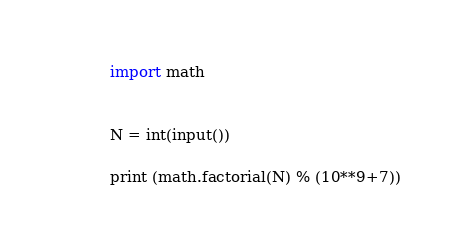<code> <loc_0><loc_0><loc_500><loc_500><_Python_>import math


N = int(input())

print (math.factorial(N) % (10**9+7))
</code> 